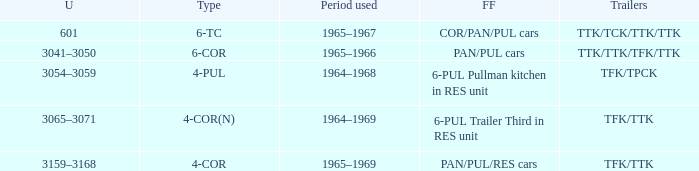Could you parse the entire table? {'header': ['U', 'Type', 'Period used', 'FF', 'Trailers'], 'rows': [['601', '6-TC', '1965–1967', 'COR/PAN/PUL cars', 'TTK/TCK/TTK/TTK'], ['3041–3050', '6-COR', '1965–1966', 'PAN/PUL cars', 'TTK/TTK/TFK/TTK'], ['3054–3059', '4-PUL', '1964–1968', '6-PUL Pullman kitchen in RES unit', 'TFK/TPCK'], ['3065–3071', '4-COR(N)', '1964–1969', '6-PUL Trailer Third in RES unit', 'TFK/TTK'], ['3159–3168', '4-COR', '1965–1969', 'PAN/PUL/RES cars', 'TFK/TTK']]} Name the typed for formed from 6-pul trailer third in res unit 4-COR(N). 